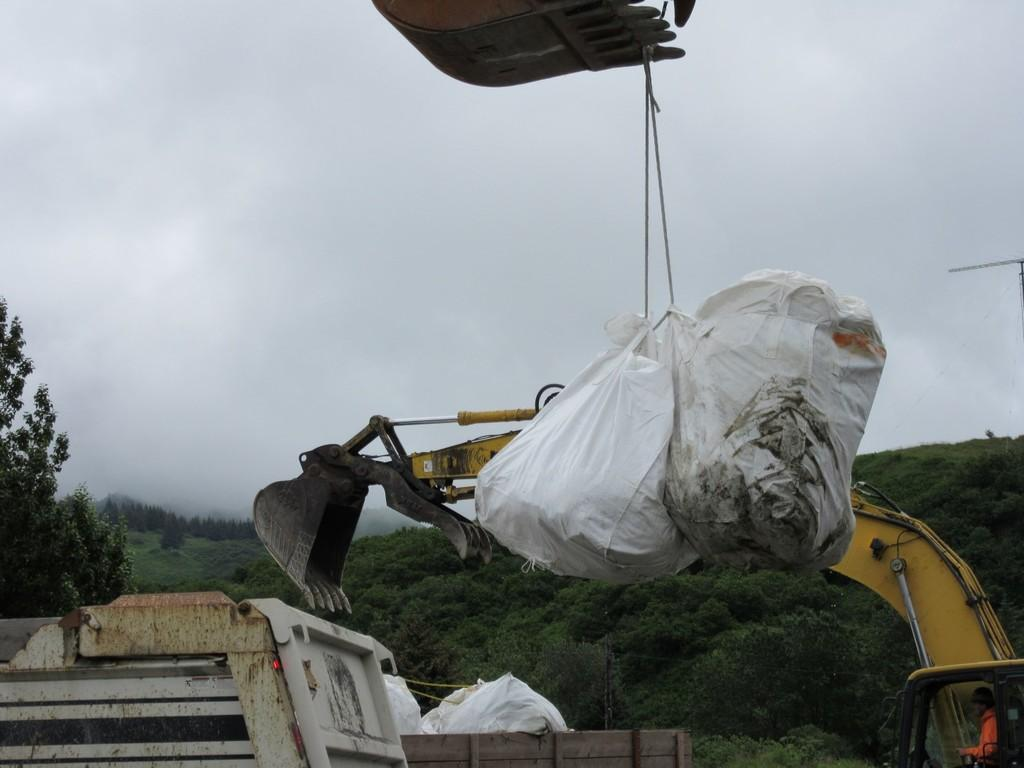What type of vehicle is in the image? There is a vehicle in the image, but the specific type is not mentioned. What is the plastic bag used for in the image? The purpose of the plastic bag in the image is not clear. What is the rope used for in the image? The use of the rope in the image is not specified. What type of vegetation is in the image? There are trees in the image. What geographical feature is in the image? There is a mountain in the image. What is the weather like in the image? The sky is cloudy in the image. What is the person wearing in the image? There is a person wearing clothes in the image. What type of credit card is the person using in the image? There is no credit card or any indication of financial transactions in the image. What type of drug is the person taking in the image? There is no drug or any indication of substance use in the image. What type of organization is the person representing in the image? There is no indication of any organization or affiliation in the image. 